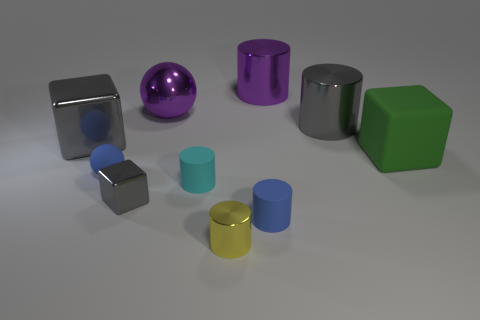What number of other things are made of the same material as the large purple sphere?
Your response must be concise. 5. There is a big metallic cylinder that is behind the large gray thing to the right of the big cube that is left of the gray cylinder; what is its color?
Ensure brevity in your answer.  Purple. The matte object that is right of the big purple metallic object on the right side of the yellow metallic cylinder is what shape?
Make the answer very short. Cube. Is the number of tiny cyan rubber cylinders that are behind the cyan object greater than the number of large green things?
Offer a terse response. No. There is a object left of the matte ball; is it the same shape as the green rubber thing?
Provide a short and direct response. Yes. Are there any small gray rubber things that have the same shape as the large green object?
Provide a short and direct response. No. What number of things are either metallic things that are in front of the small gray shiny cube or big gray shiny things?
Your answer should be compact. 3. Is the number of tiny cyan metal cylinders greater than the number of large gray cubes?
Keep it short and to the point. No. Is there a cyan metallic block of the same size as the green rubber object?
Provide a succinct answer. No. How many objects are either small things that are right of the small cyan cylinder or rubber objects that are on the right side of the metallic sphere?
Your response must be concise. 4. 